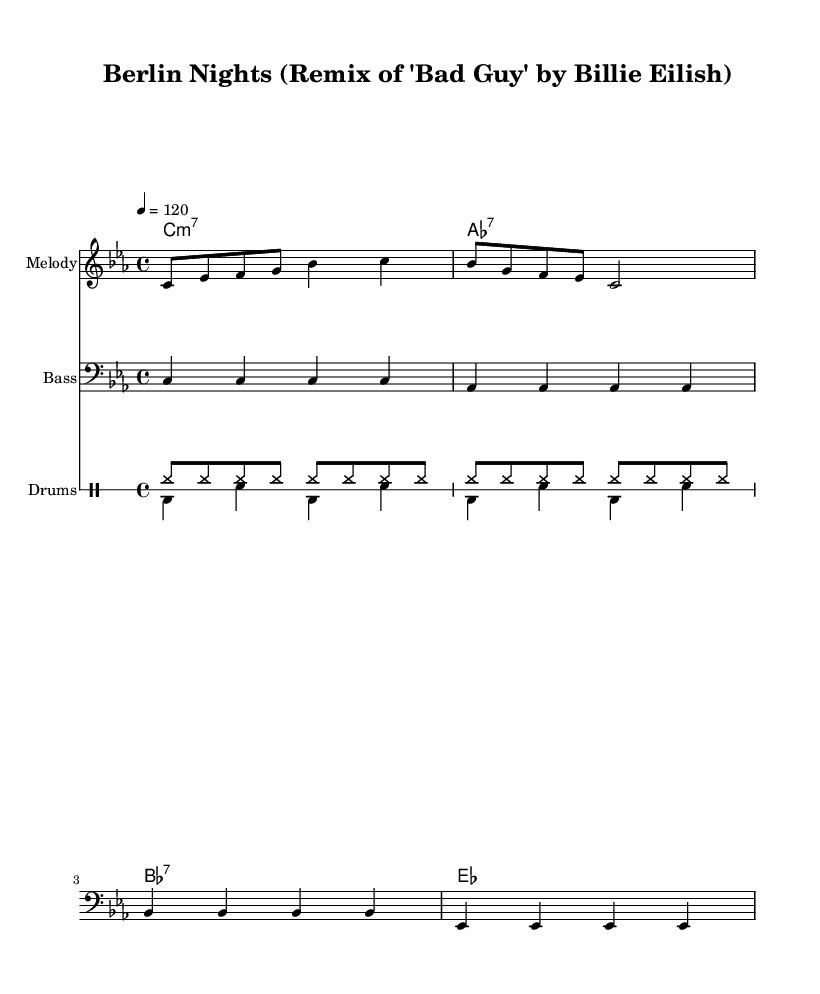What is the key signature of this music? The key signature is C minor, which has three flats (B♭, E♭, and A♭). This is indicated in the global section of the code where \key c \minor is specified.
Answer: C minor What is the time signature of this music? The time signature is 4/4, which means there are four beats in a measure and the quarter note gets one beat. This is found in the global section of the code with the \time 4/4 protocol.
Answer: 4/4 What is the tempo of the piece? The tempo is set at 120 beats per minute, as indicated by the tempo marking in the global section, which reads \tempo 4 = 120.
Answer: 120 How many measures are in the melody section? The melody section has a total of 4 measures. This can be counted by identifying the groups of 4 beats, as per the 4/4 time signature, and looking at the notation provided.
Answer: 4 What type of chord is indicated at the beginning of the music? The first chord indicated is a C minor 7 (m7), shown in the chordNames section with the notation c1:m7, denoting a minor chord with an additional seventh.
Answer: C minor 7 Which instrument is notated in the bass clef in the music? The instrument specified to use the bass clef in the music is the bass, as indicated by the \clef bass command in the bass section of the code.
Answer: Bass What rhythmic elements are predominantly used in the drum section? The rhythmic elements in the drum section include hi-hats and bass drum snaps, as shown in the drumUp and drumDown sections, which represent common disco rhythm patterns.
Answer: Hi-hats and bass drums 